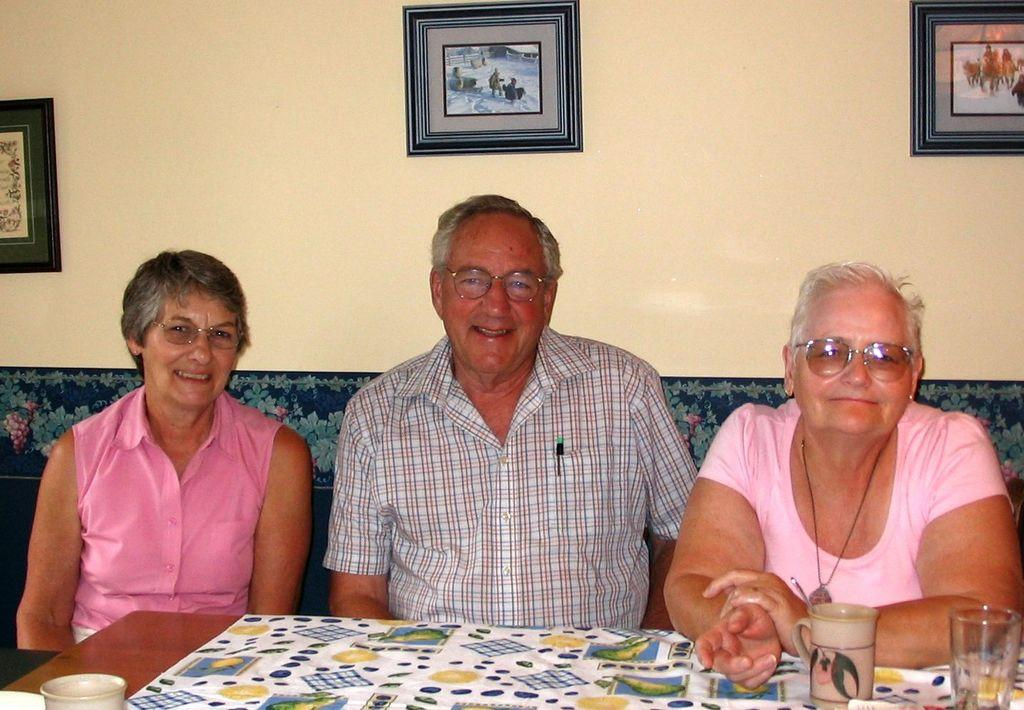How many people are sitting in the image? There are three people sitting in the image. What is in front of the people? There is a table in front of the people. What can be found on the table? There are objects on the table. What is on the wall behind the people? There is a wall with three different photo frames in the image. What type of chess pieces are visible on the table in the image? There is no chess set present on the table in the image. What arithmetic problem can be solved using the objects on the table? There is no arithmetic problem or objects related to arithmetic present on the table in the image. 